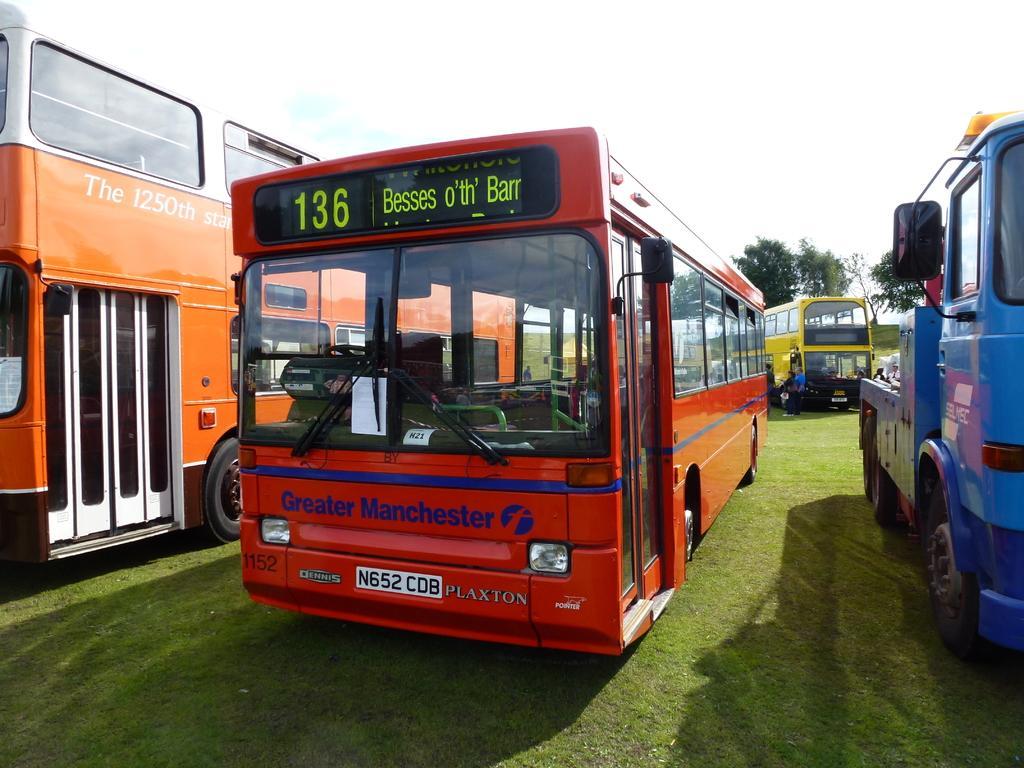Describe this image in one or two sentences. In this image, we can see buses and some people standing. In the background, there are trees. 